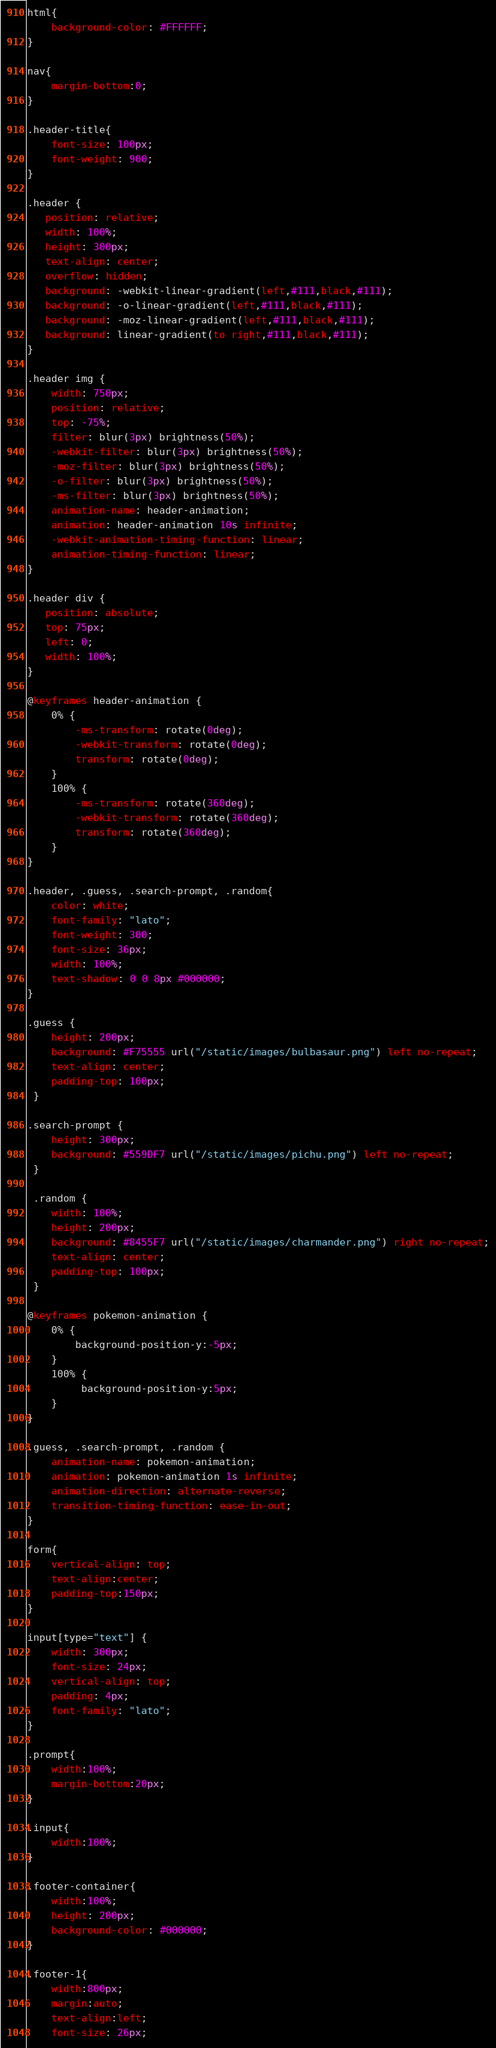Convert code to text. <code><loc_0><loc_0><loc_500><loc_500><_CSS_>html{
    background-color: #FFFFFF;
}

nav{
    margin-bottom:0;
}

.header-title{
    font-size: 100px;
    font-weight: 900;
}

.header {
   position: relative;
   width: 100%;
   height: 300px;
   text-align: center;
   overflow: hidden;
   background: -webkit-linear-gradient(left,#111,black,#111);
   background: -o-linear-gradient(left,#111,black,#111);
   background: -moz-linear-gradient(left,#111,black,#111);
   background: linear-gradient(to right,#111,black,#111);
}

.header img {
    width: 750px;
    position: relative;
    top: -75%;
    filter: blur(3px) brightness(50%);
    -webkit-filter: blur(3px) brightness(50%);
    -moz-filter: blur(3px) brightness(50%);
    -o-filter: blur(3px) brightness(50%);
    -ms-filter: blur(3px) brightness(50%);
    animation-name: header-animation;
    animation: header-animation 10s infinite;
    -webkit-animation-timing-function: linear;
    animation-timing-function: linear;
}

.header div {
   position: absolute;
   top: 75px;
   left: 0;
   width: 100%;
}

@keyframes header-animation {
    0% {
        -ms-transform: rotate(0deg);
        -webkit-transform: rotate(0deg);
        transform: rotate(0deg);
    }
    100% {
        -ms-transform: rotate(360deg);
        -webkit-transform: rotate(360deg);
        transform: rotate(360deg);
    }
}

.header, .guess, .search-prompt, .random{
    color: white;
    font-family: "lato";
    font-weight: 300;
    font-size: 36px;
    width: 100%;
    text-shadow: 0 0 8px #000000;
}

.guess {
    height: 200px;
    background: #F75555 url("/static/images/bulbasaur.png") left no-repeat;
    text-align: center;
    padding-top: 100px;
 }

.search-prompt {
    height: 300px;
    background: #559DF7 url("/static/images/pichu.png") left no-repeat;
 }

 .random {
    width: 100%;
    height: 200px;
    background: #8455F7 url("/static/images/charmander.png") right no-repeat;
    text-align: center;
    padding-top: 100px;
 }

@keyframes pokemon-animation {
    0% {
        background-position-y:-5px;
    }
    100% {
         background-position-y:5px;
    }
}

.guess, .search-prompt, .random {
    animation-name: pokemon-animation;
    animation: pokemon-animation 1s infinite;
    animation-direction: alternate-reverse;
    transition-timing-function: ease-in-out;
}

form{
    vertical-align: top;
    text-align:center;
    padding-top:150px;
}

input[type="text"] {
    width: 300px;
    font-size: 24px;
    vertical-align: top;
    padding: 4px;
    font-family: "lato";
}

.prompt{
    width:100%;
    margin-bottom:20px;
}

.input{
    width:100%;
}

.footer-container{
    width:100%;
    height: 200px;
    background-color: #000000;
}

.footer-1{
    width:800px;
    margin:auto;
    text-align:left;
    font-size: 26px;</code> 